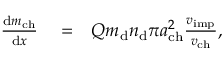Convert formula to latex. <formula><loc_0><loc_0><loc_500><loc_500>\begin{array} { r l r } { \frac { d m _ { c h } } { d x } } & = } & { Q m _ { d } n _ { d } \pi a _ { c h } ^ { 2 } \frac { v _ { i m p } } { v _ { c h } } , } \end{array}</formula> 